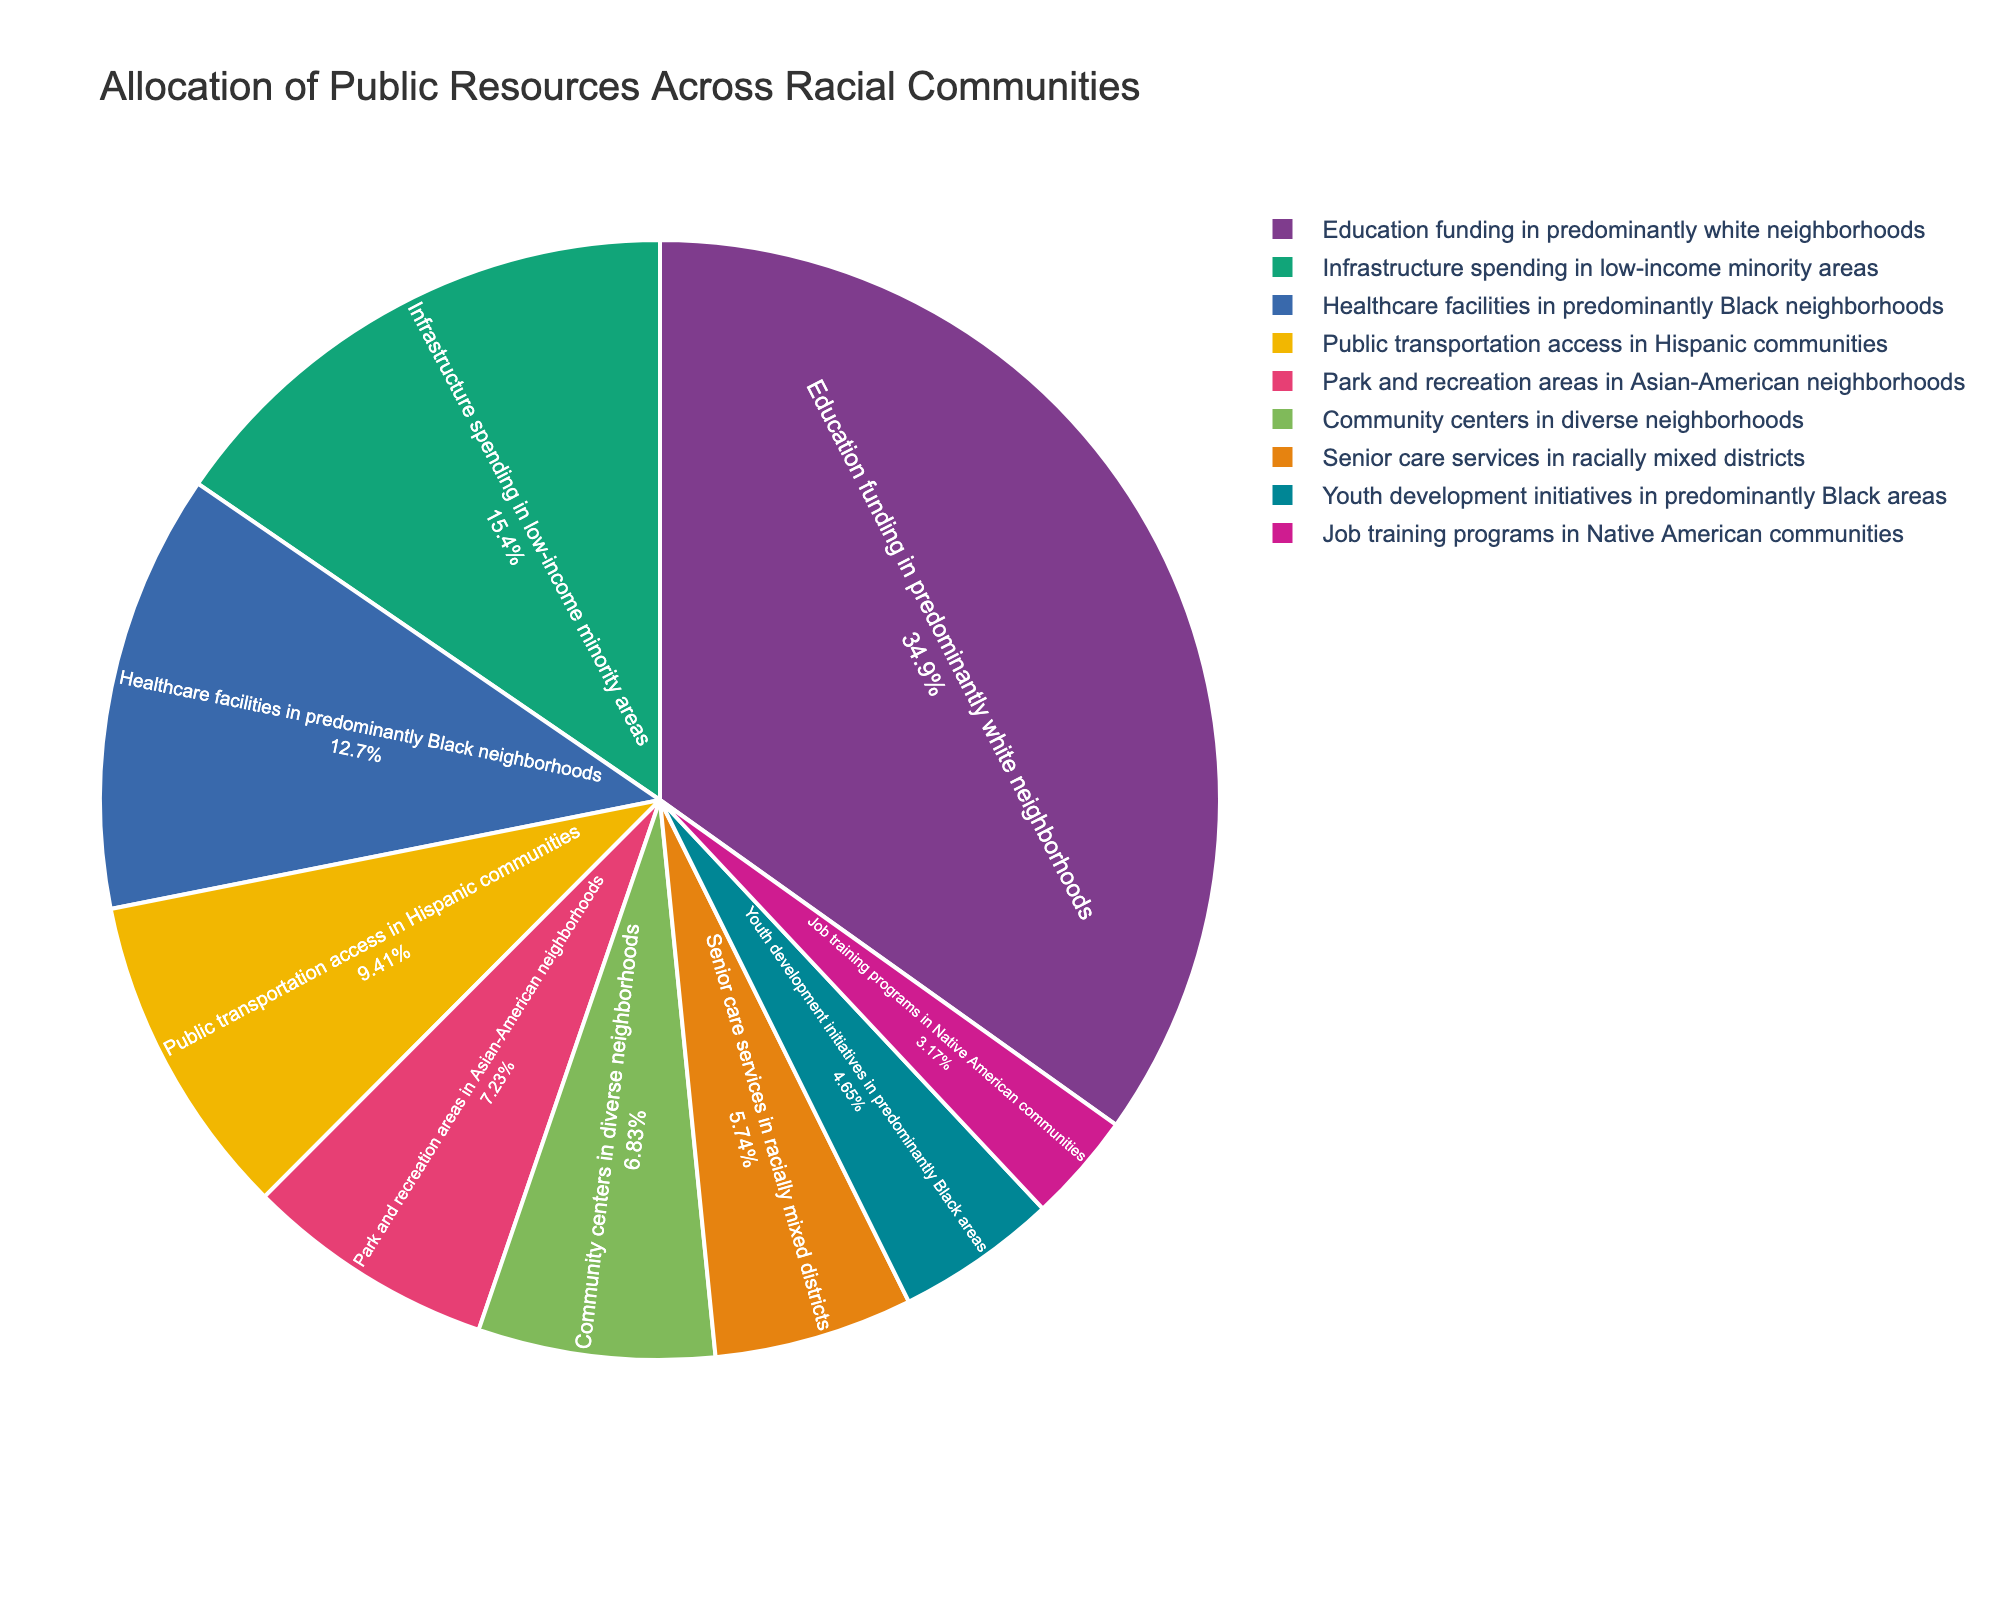Which category receives the highest percentage of public resources? By looking at the pie chart, we can see that the section labeled "Education funding in predominantly white neighborhoods" is the largest, indicating it receives the highest percentage of public resources.
Answer: Education funding in predominantly white neighborhoods Which two categories combined receive more resources: "Healthcare facilities in predominantly Black neighborhoods" and "Infrastructure spending in low-income minority areas" or "Education funding in predominantly white neighborhoods"? First, sum the percentages for "Healthcare facilities in predominantly Black neighborhoods" (12.8) and "Infrastructure spending in low-income minority areas" (15.6), which equals 28.4%. Then, compare this to "Education funding in predominantly white neighborhoods," which is 35.2%. Since 35.2% is greater than 28.4%, "Education funding in predominantly white neighborhoods" receives more resources.
Answer: Education funding in predominantly white neighborhoods What is the percentage difference between "Public transportation access in Hispanic communities" and "Youth development initiatives in predominantly Black areas"? Subtract the percentage of "Youth development initiatives in predominantly Black areas" (4.7%) from "Public transportation access in Hispanic communities" (9.5%). The difference is 9.5% - 4.7% = 4.8%.
Answer: 4.8% Which category receives a lower percentage of resources: "Community centers in diverse neighborhoods" or "Senior care services in racially mixed districts"? Compare the percentages for "Community centers in diverse neighborhoods" (6.9%) and "Senior care services in racially mixed districts" (5.8%). Since 5.8% is lower than 6.9%, "Senior care services in racially mixed districts" receives a lower percentage.
Answer: Senior care services in racially mixed districts Is the allocation for "Job training programs in Native American communities" more or less than half the allocation for "Education funding in predominantly white neighborhoods"? First, find half of the allocation for "Education funding in predominantly white neighborhoods," which is 35.2% / 2 = 17.6%. Compare this with the allocation for "Job training programs in Native American communities" (3.2%). Since 3.2% is less than 17.6%, it is less than half.
Answer: Less Which category receives the second highest allocation of public resources? By examining the pie chart, the section with the second largest area is "Infrastructure spending in low-income minority areas," which indicates the second highest allocation.
Answer: Infrastructure spending in low-income minority areas How much higher is the allocation for "Education funding in predominantly white neighborhoods" compared to "Public transportation access in Hispanic communities"? Subtract the percentage for "Public transportation access in Hispanic communities" (9.5%) from "Education funding in predominantly white neighborhoods" (35.2%). The difference is 35.2% - 9.5% = 25.7%.
Answer: 25.7% Calculate the total percentage of resources allocated to predominantly Black and Hispanic communities. Add the percentages for "Healthcare facilities in predominantly Black neighborhoods" (12.8%), "Youth development initiatives in predominantly Black areas" (4.7%), and "Public transportation access in Hispanic communities" (9.5%). The total is 12.8% + 4.7% + 9.5% = 27%.
Answer: 27% What is the total percentage of resources allocated to neighborhoods with diverse racial composition, including "Community centers in diverse neighborhoods" and "Senior care services in racially mixed districts"? Add the percentages for "Community centers in diverse neighborhoods" (6.9%) and "Senior care services in racially mixed districts" (5.8%). The total is 6.9% + 5.8% = 12.7%.
Answer: 12.7% Identify the category with the smallest allocation of public resources in the pie chart. By observing the smallest section in the pie chart, we see that "Job training programs in Native American communities" has the smallest allocation at 3.2%.
Answer: Job training programs in Native American communities 